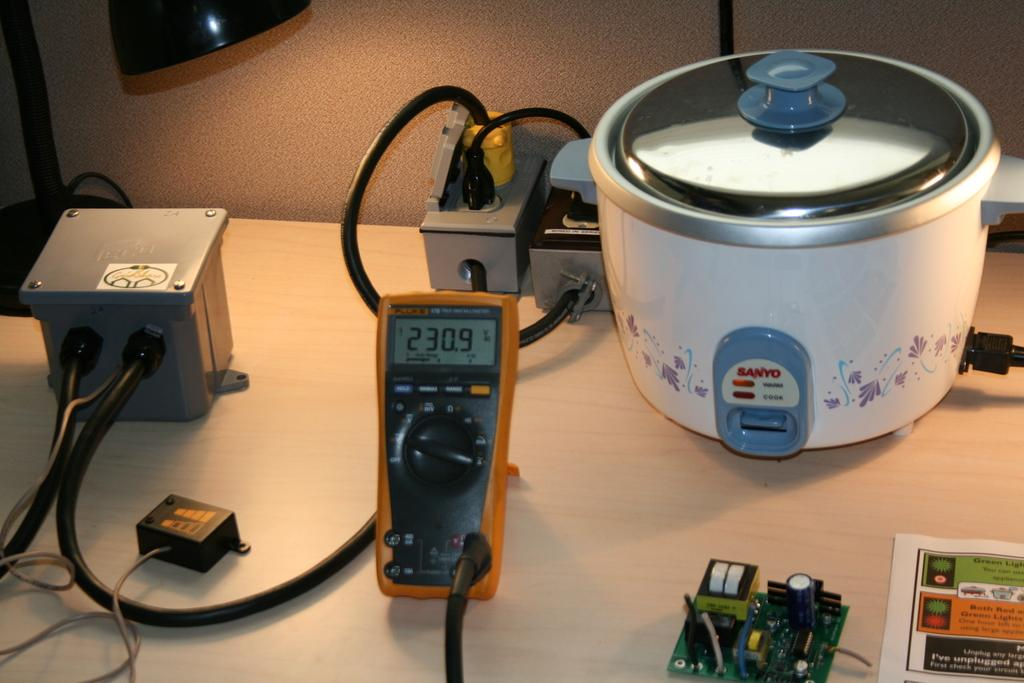What piece of furniture is in the image? There is a table in the image. What appliance is placed on the table? A rice cooker is placed on the table. What else can be seen on the table? Wires, electronic devices, and a paper are present on the table. What type of light source is in the image? There is a lamp in the image. What is visible in the background of the image? There is a wall visible in the image. Can you see the body language of the cup in the image? There is no cup present in the image, so it is not possible to observe its body language. 